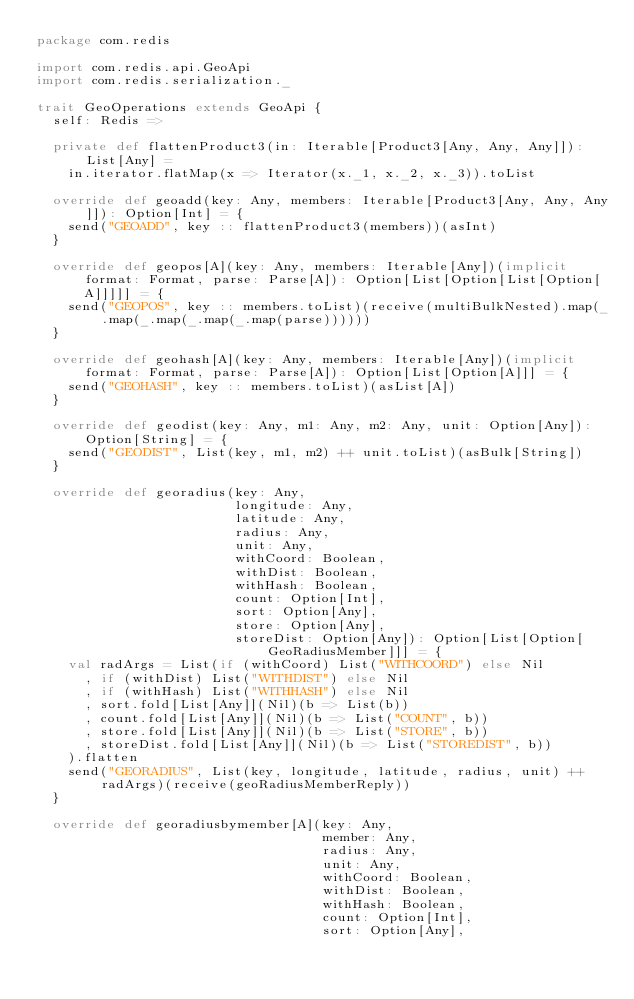Convert code to text. <code><loc_0><loc_0><loc_500><loc_500><_Scala_>package com.redis

import com.redis.api.GeoApi
import com.redis.serialization._

trait GeoOperations extends GeoApi {
  self: Redis =>

  private def flattenProduct3(in: Iterable[Product3[Any, Any, Any]]): List[Any] =
    in.iterator.flatMap(x => Iterator(x._1, x._2, x._3)).toList

  override def geoadd(key: Any, members: Iterable[Product3[Any, Any, Any]]): Option[Int] = {
    send("GEOADD", key :: flattenProduct3(members))(asInt)
  }

  override def geopos[A](key: Any, members: Iterable[Any])(implicit format: Format, parse: Parse[A]): Option[List[Option[List[Option[A]]]]] = {
    send("GEOPOS", key :: members.toList)(receive(multiBulkNested).map(_.map(_.map(_.map(_.map(parse))))))
  }

  override def geohash[A](key: Any, members: Iterable[Any])(implicit format: Format, parse: Parse[A]): Option[List[Option[A]]] = {
    send("GEOHASH", key :: members.toList)(asList[A])
  }

  override def geodist(key: Any, m1: Any, m2: Any, unit: Option[Any]): Option[String] = {
    send("GEODIST", List(key, m1, m2) ++ unit.toList)(asBulk[String])
  }

  override def georadius(key: Any,
                         longitude: Any,
                         latitude: Any,
                         radius: Any,
                         unit: Any,
                         withCoord: Boolean,
                         withDist: Boolean,
                         withHash: Boolean,
                         count: Option[Int],
                         sort: Option[Any],
                         store: Option[Any],
                         storeDist: Option[Any]): Option[List[Option[GeoRadiusMember]]] = {
    val radArgs = List(if (withCoord) List("WITHCOORD") else Nil
      , if (withDist) List("WITHDIST") else Nil
      , if (withHash) List("WITHHASH") else Nil
      , sort.fold[List[Any]](Nil)(b => List(b))
      , count.fold[List[Any]](Nil)(b => List("COUNT", b))
      , store.fold[List[Any]](Nil)(b => List("STORE", b))
      , storeDist.fold[List[Any]](Nil)(b => List("STOREDIST", b))
    ).flatten
    send("GEORADIUS", List(key, longitude, latitude, radius, unit) ++ radArgs)(receive(geoRadiusMemberReply))
  }

  override def georadiusbymember[A](key: Any,
                                    member: Any,
                                    radius: Any,
                                    unit: Any,
                                    withCoord: Boolean,
                                    withDist: Boolean,
                                    withHash: Boolean,
                                    count: Option[Int],
                                    sort: Option[Any],</code> 